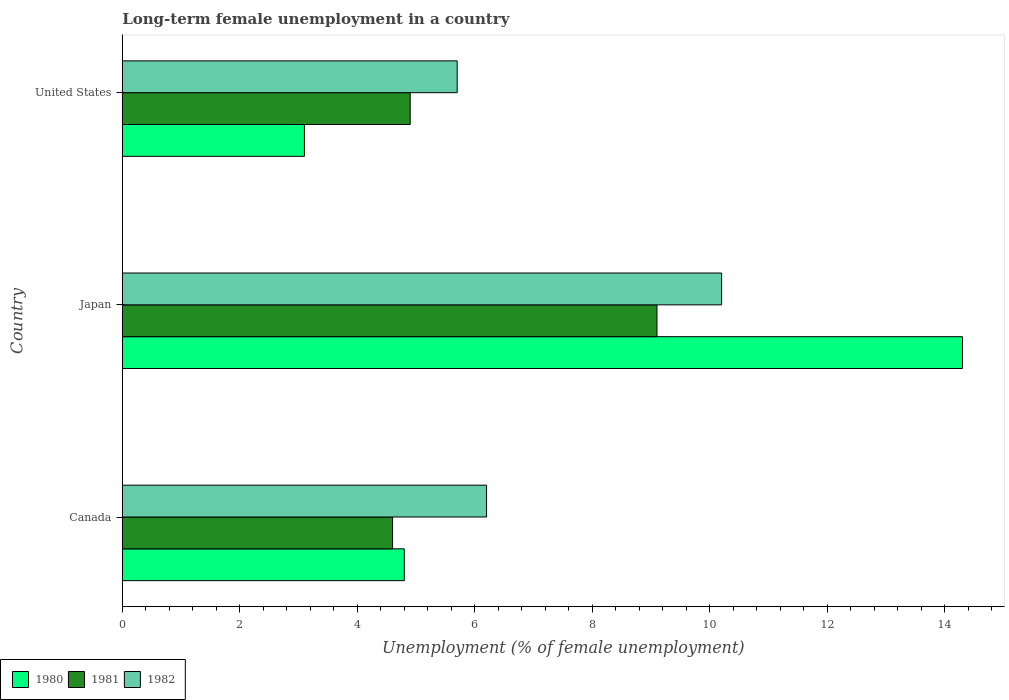How many different coloured bars are there?
Your answer should be very brief. 3. How many bars are there on the 2nd tick from the top?
Your response must be concise. 3. What is the percentage of long-term unemployed female population in 1980 in United States?
Provide a succinct answer. 3.1. Across all countries, what is the maximum percentage of long-term unemployed female population in 1980?
Give a very brief answer. 14.3. Across all countries, what is the minimum percentage of long-term unemployed female population in 1982?
Provide a short and direct response. 5.7. In which country was the percentage of long-term unemployed female population in 1981 maximum?
Make the answer very short. Japan. What is the total percentage of long-term unemployed female population in 1980 in the graph?
Offer a very short reply. 22.2. What is the difference between the percentage of long-term unemployed female population in 1982 in Japan and that in United States?
Your answer should be compact. 4.5. What is the difference between the percentage of long-term unemployed female population in 1981 in Japan and the percentage of long-term unemployed female population in 1980 in United States?
Make the answer very short. 6. What is the average percentage of long-term unemployed female population in 1982 per country?
Provide a succinct answer. 7.37. What is the difference between the percentage of long-term unemployed female population in 1981 and percentage of long-term unemployed female population in 1980 in United States?
Make the answer very short. 1.8. In how many countries, is the percentage of long-term unemployed female population in 1981 greater than 11.6 %?
Offer a very short reply. 0. What is the ratio of the percentage of long-term unemployed female population in 1980 in Japan to that in United States?
Ensure brevity in your answer.  4.61. What is the difference between the highest and the second highest percentage of long-term unemployed female population in 1982?
Your answer should be compact. 4. What is the difference between the highest and the lowest percentage of long-term unemployed female population in 1982?
Your answer should be compact. 4.5. Is the sum of the percentage of long-term unemployed female population in 1980 in Canada and United States greater than the maximum percentage of long-term unemployed female population in 1981 across all countries?
Ensure brevity in your answer.  No. What does the 1st bar from the top in Canada represents?
Your response must be concise. 1982. Are all the bars in the graph horizontal?
Make the answer very short. Yes. What is the difference between two consecutive major ticks on the X-axis?
Provide a short and direct response. 2. Are the values on the major ticks of X-axis written in scientific E-notation?
Ensure brevity in your answer.  No. Does the graph contain any zero values?
Give a very brief answer. No. Where does the legend appear in the graph?
Your answer should be compact. Bottom left. How many legend labels are there?
Provide a short and direct response. 3. How are the legend labels stacked?
Your answer should be compact. Horizontal. What is the title of the graph?
Give a very brief answer. Long-term female unemployment in a country. Does "1977" appear as one of the legend labels in the graph?
Provide a succinct answer. No. What is the label or title of the X-axis?
Your response must be concise. Unemployment (% of female unemployment). What is the Unemployment (% of female unemployment) of 1980 in Canada?
Make the answer very short. 4.8. What is the Unemployment (% of female unemployment) of 1981 in Canada?
Provide a short and direct response. 4.6. What is the Unemployment (% of female unemployment) of 1982 in Canada?
Your answer should be compact. 6.2. What is the Unemployment (% of female unemployment) of 1980 in Japan?
Offer a very short reply. 14.3. What is the Unemployment (% of female unemployment) in 1981 in Japan?
Provide a short and direct response. 9.1. What is the Unemployment (% of female unemployment) in 1982 in Japan?
Offer a very short reply. 10.2. What is the Unemployment (% of female unemployment) of 1980 in United States?
Provide a short and direct response. 3.1. What is the Unemployment (% of female unemployment) in 1981 in United States?
Provide a short and direct response. 4.9. What is the Unemployment (% of female unemployment) in 1982 in United States?
Provide a succinct answer. 5.7. Across all countries, what is the maximum Unemployment (% of female unemployment) in 1980?
Ensure brevity in your answer.  14.3. Across all countries, what is the maximum Unemployment (% of female unemployment) in 1981?
Make the answer very short. 9.1. Across all countries, what is the maximum Unemployment (% of female unemployment) in 1982?
Provide a short and direct response. 10.2. Across all countries, what is the minimum Unemployment (% of female unemployment) in 1980?
Give a very brief answer. 3.1. Across all countries, what is the minimum Unemployment (% of female unemployment) of 1981?
Provide a short and direct response. 4.6. Across all countries, what is the minimum Unemployment (% of female unemployment) of 1982?
Give a very brief answer. 5.7. What is the total Unemployment (% of female unemployment) of 1981 in the graph?
Provide a succinct answer. 18.6. What is the total Unemployment (% of female unemployment) in 1982 in the graph?
Your response must be concise. 22.1. What is the difference between the Unemployment (% of female unemployment) in 1981 in Japan and that in United States?
Ensure brevity in your answer.  4.2. What is the difference between the Unemployment (% of female unemployment) in 1981 in Canada and the Unemployment (% of female unemployment) in 1982 in United States?
Make the answer very short. -1.1. What is the difference between the Unemployment (% of female unemployment) of 1981 in Japan and the Unemployment (% of female unemployment) of 1982 in United States?
Give a very brief answer. 3.4. What is the average Unemployment (% of female unemployment) in 1981 per country?
Your answer should be very brief. 6.2. What is the average Unemployment (% of female unemployment) of 1982 per country?
Keep it short and to the point. 7.37. What is the difference between the Unemployment (% of female unemployment) in 1981 and Unemployment (% of female unemployment) in 1982 in Canada?
Give a very brief answer. -1.6. What is the difference between the Unemployment (% of female unemployment) of 1980 and Unemployment (% of female unemployment) of 1981 in Japan?
Make the answer very short. 5.2. What is the difference between the Unemployment (% of female unemployment) of 1980 and Unemployment (% of female unemployment) of 1982 in Japan?
Provide a short and direct response. 4.1. What is the difference between the Unemployment (% of female unemployment) of 1981 and Unemployment (% of female unemployment) of 1982 in Japan?
Give a very brief answer. -1.1. What is the difference between the Unemployment (% of female unemployment) of 1980 and Unemployment (% of female unemployment) of 1981 in United States?
Offer a terse response. -1.8. What is the difference between the Unemployment (% of female unemployment) of 1980 and Unemployment (% of female unemployment) of 1982 in United States?
Your answer should be very brief. -2.6. What is the difference between the Unemployment (% of female unemployment) in 1981 and Unemployment (% of female unemployment) in 1982 in United States?
Offer a very short reply. -0.8. What is the ratio of the Unemployment (% of female unemployment) of 1980 in Canada to that in Japan?
Offer a terse response. 0.34. What is the ratio of the Unemployment (% of female unemployment) in 1981 in Canada to that in Japan?
Make the answer very short. 0.51. What is the ratio of the Unemployment (% of female unemployment) of 1982 in Canada to that in Japan?
Offer a terse response. 0.61. What is the ratio of the Unemployment (% of female unemployment) in 1980 in Canada to that in United States?
Ensure brevity in your answer.  1.55. What is the ratio of the Unemployment (% of female unemployment) of 1981 in Canada to that in United States?
Ensure brevity in your answer.  0.94. What is the ratio of the Unemployment (% of female unemployment) in 1982 in Canada to that in United States?
Your answer should be compact. 1.09. What is the ratio of the Unemployment (% of female unemployment) of 1980 in Japan to that in United States?
Your response must be concise. 4.61. What is the ratio of the Unemployment (% of female unemployment) in 1981 in Japan to that in United States?
Keep it short and to the point. 1.86. What is the ratio of the Unemployment (% of female unemployment) in 1982 in Japan to that in United States?
Offer a terse response. 1.79. What is the difference between the highest and the second highest Unemployment (% of female unemployment) of 1981?
Provide a short and direct response. 4.2. What is the difference between the highest and the lowest Unemployment (% of female unemployment) in 1980?
Ensure brevity in your answer.  11.2. What is the difference between the highest and the lowest Unemployment (% of female unemployment) of 1981?
Ensure brevity in your answer.  4.5. What is the difference between the highest and the lowest Unemployment (% of female unemployment) of 1982?
Keep it short and to the point. 4.5. 